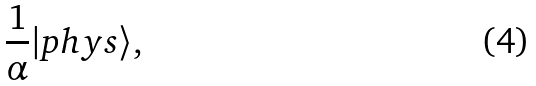Convert formula to latex. <formula><loc_0><loc_0><loc_500><loc_500>\frac { 1 } { \alpha } | p h y s \rangle ,</formula> 